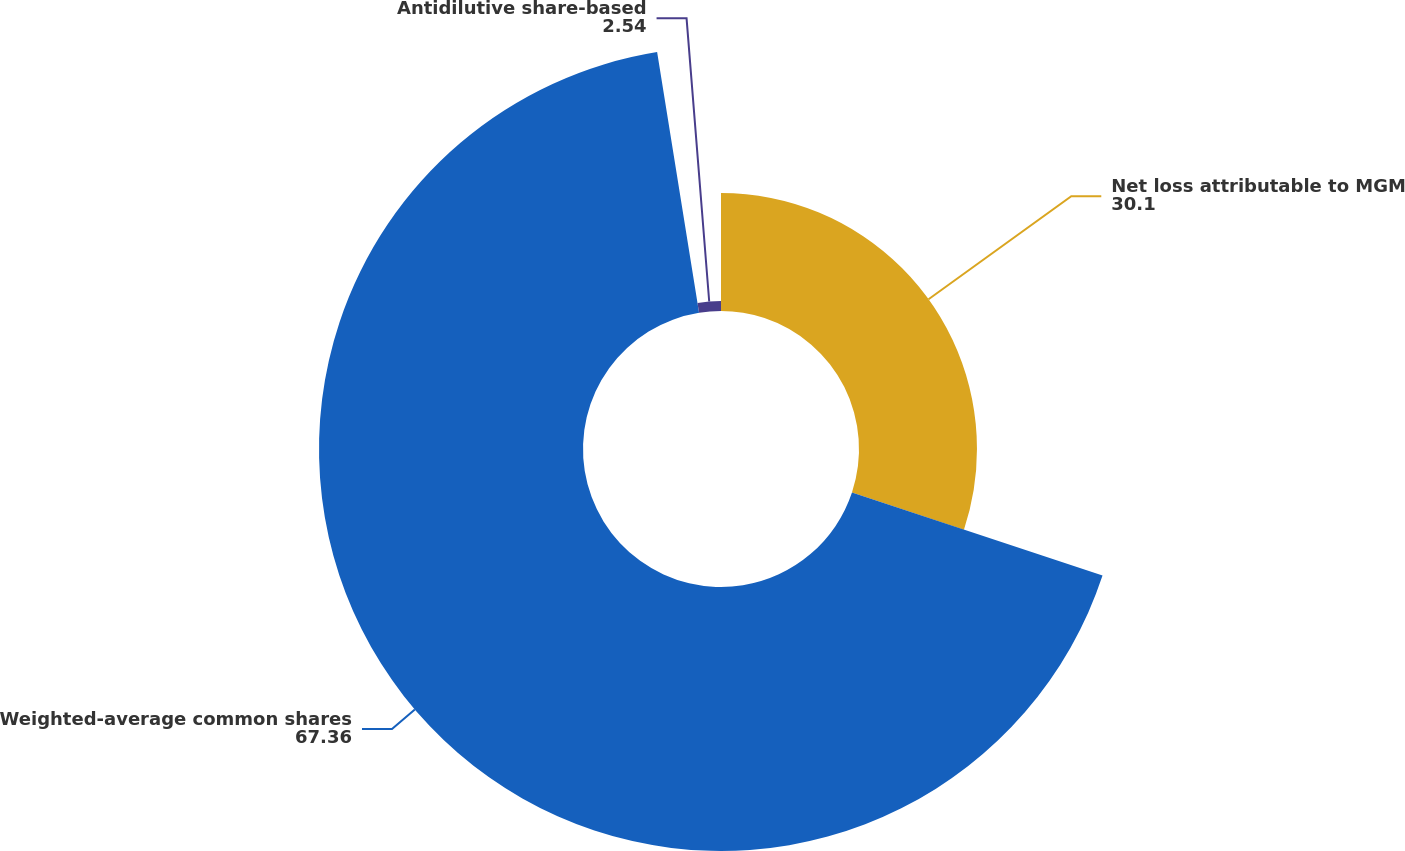<chart> <loc_0><loc_0><loc_500><loc_500><pie_chart><fcel>Net loss attributable to MGM<fcel>Weighted-average common shares<fcel>Antidilutive share-based<nl><fcel>30.1%<fcel>67.36%<fcel>2.54%<nl></chart> 